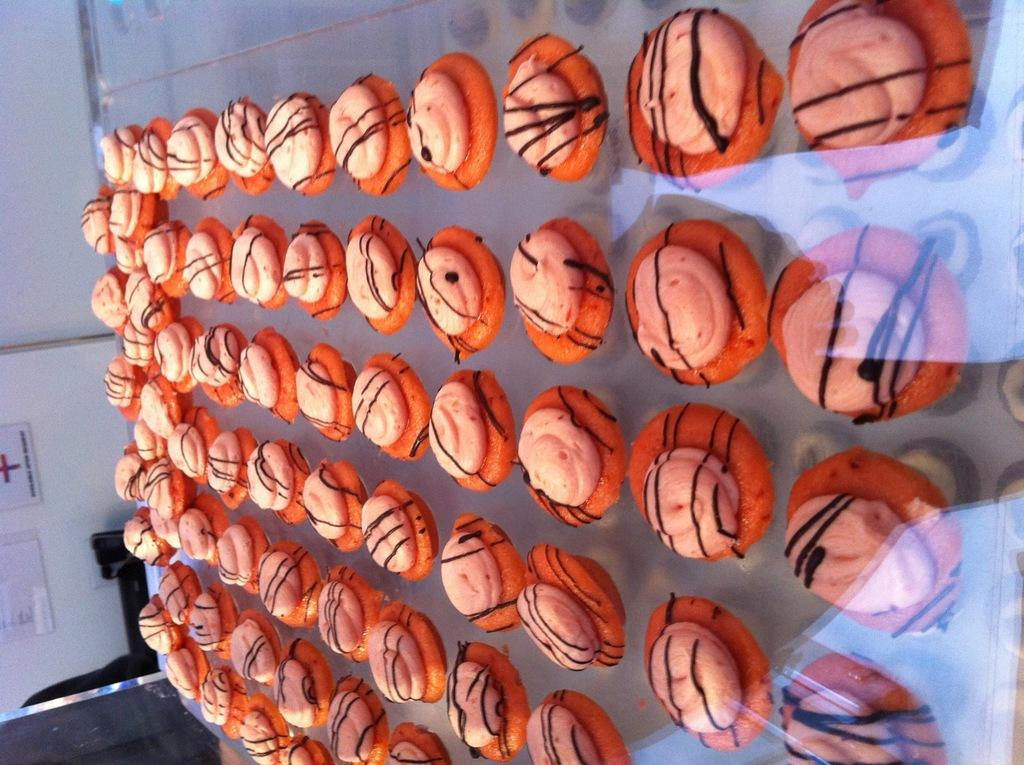What can be seen inside the showcase in the image? There are food items in a showcase in the image. What is located on the left side of the image? There is a wall on the left side of the image. What is written or displayed on the wall? There are boards with text on the wall. What time does the sign indicate in the image? There is no sign present in the image, so it is not possible to determine the time. 